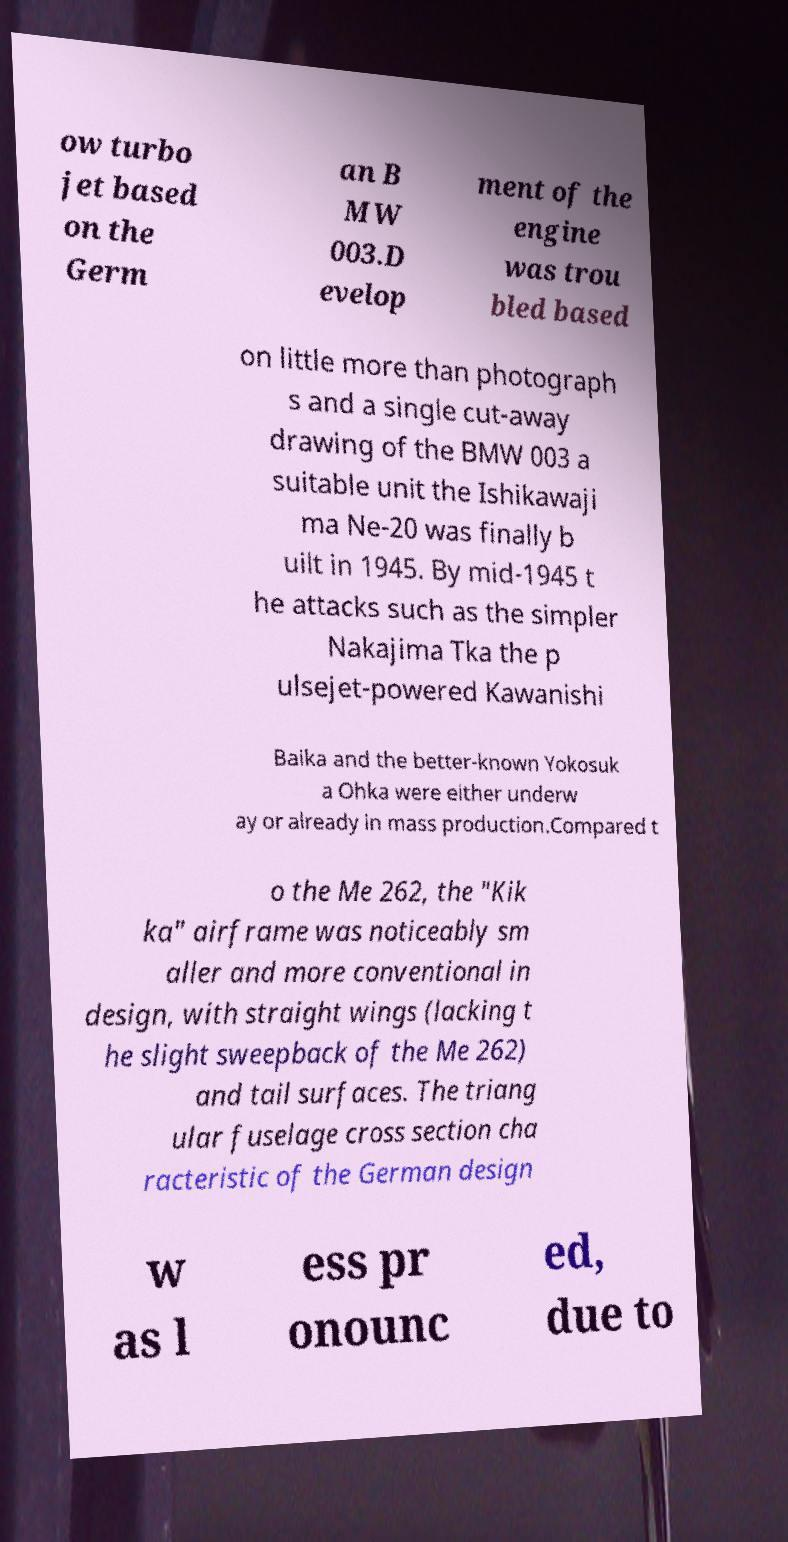Please identify and transcribe the text found in this image. ow turbo jet based on the Germ an B MW 003.D evelop ment of the engine was trou bled based on little more than photograph s and a single cut-away drawing of the BMW 003 a suitable unit the Ishikawaji ma Ne-20 was finally b uilt in 1945. By mid-1945 t he attacks such as the simpler Nakajima Tka the p ulsejet-powered Kawanishi Baika and the better-known Yokosuk a Ohka were either underw ay or already in mass production.Compared t o the Me 262, the "Kik ka" airframe was noticeably sm aller and more conventional in design, with straight wings (lacking t he slight sweepback of the Me 262) and tail surfaces. The triang ular fuselage cross section cha racteristic of the German design w as l ess pr onounc ed, due to 